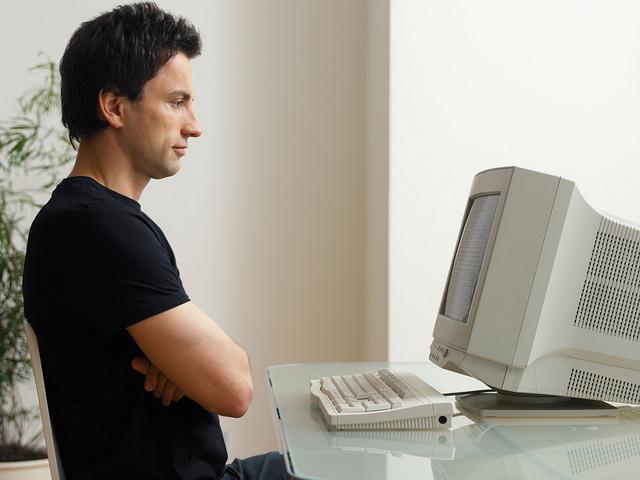Does the man have his arms crossed?
Give a very brief answer. Yes. What color is the shirt?
Write a very short answer. Black. Is this a modern computer?
Give a very brief answer. No. 